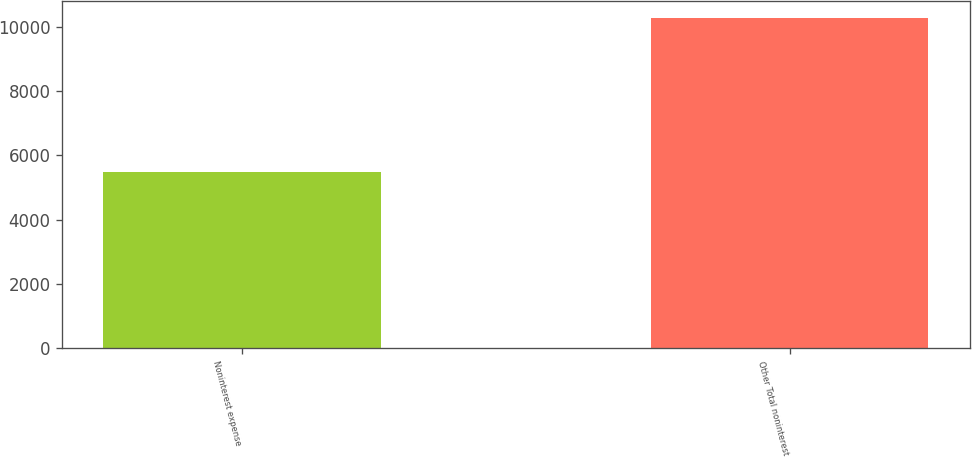Convert chart to OTSL. <chart><loc_0><loc_0><loc_500><loc_500><bar_chart><fcel>Noninterest expense<fcel>Other Total noninterest<nl><fcel>5471<fcel>10296<nl></chart> 